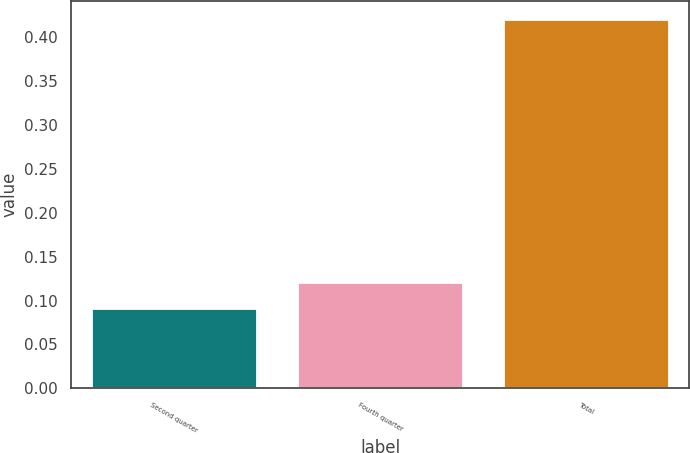<chart> <loc_0><loc_0><loc_500><loc_500><bar_chart><fcel>Second quarter<fcel>Fourth quarter<fcel>Total<nl><fcel>0.09<fcel>0.12<fcel>0.42<nl></chart> 